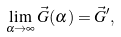<formula> <loc_0><loc_0><loc_500><loc_500>\lim _ { \alpha \rightarrow \infty } \vec { G } ( \alpha ) = \vec { G } ^ { \prime } ,</formula> 